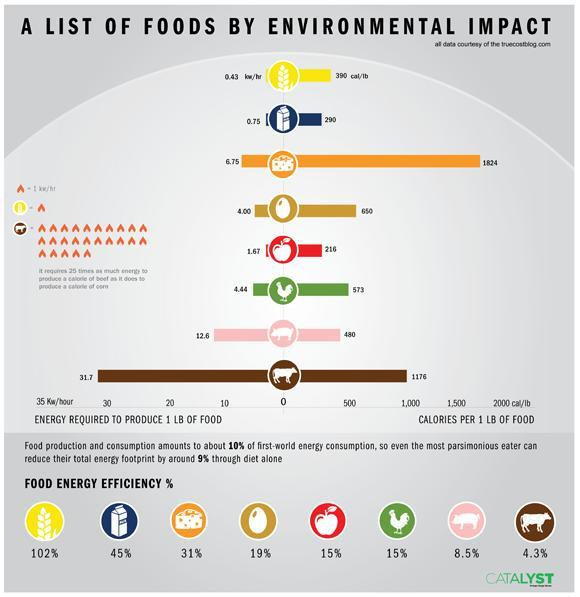what is the calories per 1 LB of beef?
Answer the question with a short phrase. 1176 which has higher energy efficiency - egg or chicken? egg what is the energy (in Kw/hour) required to produce 1 LB of beef? 31.7 what is the calories per 1 LB of chicken? 573 what is the energy (in Kw/hour) required to produce 1 LB of chicken? 4.44 what is the energy (in Kw/hour) required to produce 1 LB of egg? 4.00 what is the calories per 1 LB of milk? 290 which has higher energy efficiency - egg or milk? milk 